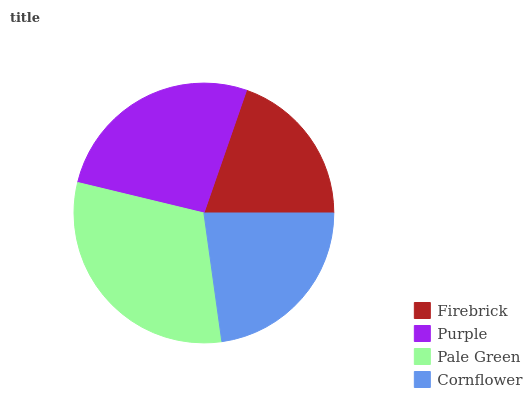Is Firebrick the minimum?
Answer yes or no. Yes. Is Pale Green the maximum?
Answer yes or no. Yes. Is Purple the minimum?
Answer yes or no. No. Is Purple the maximum?
Answer yes or no. No. Is Purple greater than Firebrick?
Answer yes or no. Yes. Is Firebrick less than Purple?
Answer yes or no. Yes. Is Firebrick greater than Purple?
Answer yes or no. No. Is Purple less than Firebrick?
Answer yes or no. No. Is Purple the high median?
Answer yes or no. Yes. Is Cornflower the low median?
Answer yes or no. Yes. Is Cornflower the high median?
Answer yes or no. No. Is Purple the low median?
Answer yes or no. No. 